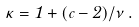<formula> <loc_0><loc_0><loc_500><loc_500>\kappa = 1 + ( c - 2 ) / \nu \, .</formula> 